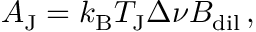<formula> <loc_0><loc_0><loc_500><loc_500>A _ { J } = k _ { B } T _ { J } \Delta \nu B _ { d i l } \, ,</formula> 